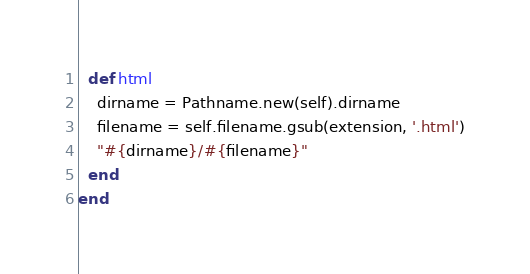Convert code to text. <code><loc_0><loc_0><loc_500><loc_500><_Ruby_>  def html
    dirname = Pathname.new(self).dirname
    filename = self.filename.gsub(extension, '.html')
    "#{dirname}/#{filename}"
  end
end
</code> 